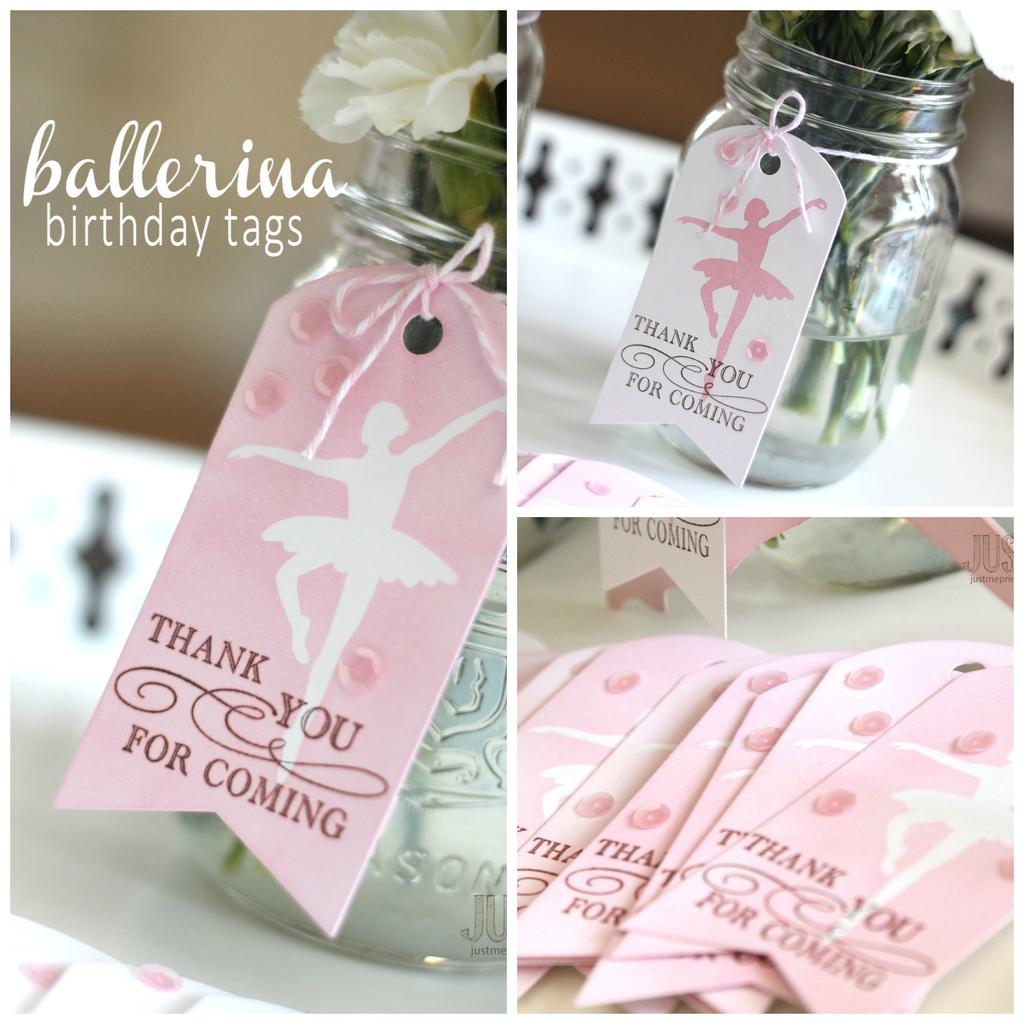What is inside the jar in the image? There is a flower in the jar. How is the jar identified or labeled? The jar is tagged with a paper. What message is written on the paper attached to the jar? The paper has the text "Thank Q For Coming" written on it. What type of juice is being served in the image? There is no juice present in the image; it features a jar with a flower and a labeled paper. 